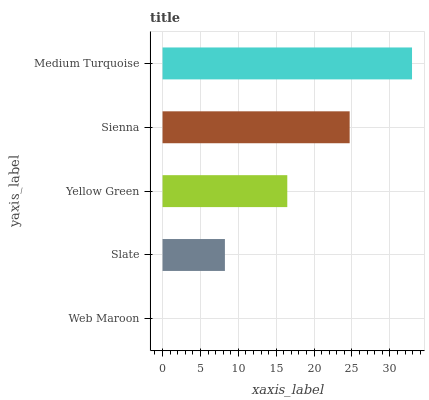Is Web Maroon the minimum?
Answer yes or no. Yes. Is Medium Turquoise the maximum?
Answer yes or no. Yes. Is Slate the minimum?
Answer yes or no. No. Is Slate the maximum?
Answer yes or no. No. Is Slate greater than Web Maroon?
Answer yes or no. Yes. Is Web Maroon less than Slate?
Answer yes or no. Yes. Is Web Maroon greater than Slate?
Answer yes or no. No. Is Slate less than Web Maroon?
Answer yes or no. No. Is Yellow Green the high median?
Answer yes or no. Yes. Is Yellow Green the low median?
Answer yes or no. Yes. Is Slate the high median?
Answer yes or no. No. Is Web Maroon the low median?
Answer yes or no. No. 